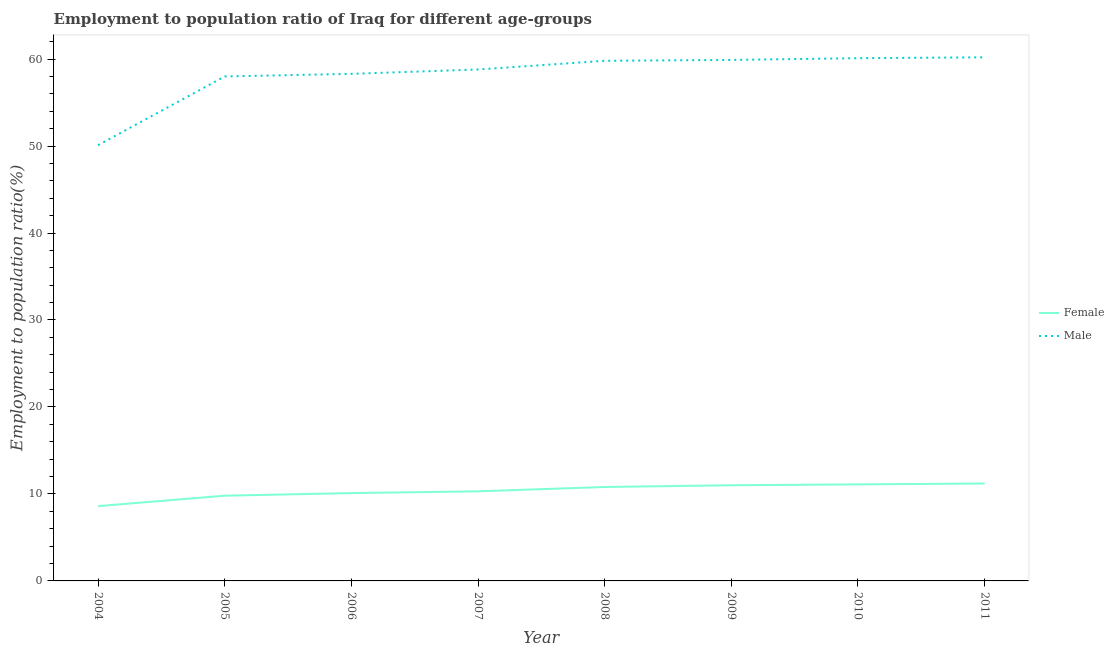Does the line corresponding to employment to population ratio(male) intersect with the line corresponding to employment to population ratio(female)?
Ensure brevity in your answer.  No. Across all years, what is the maximum employment to population ratio(male)?
Provide a succinct answer. 60.2. Across all years, what is the minimum employment to population ratio(male)?
Your answer should be compact. 50.1. In which year was the employment to population ratio(male) minimum?
Provide a short and direct response. 2004. What is the total employment to population ratio(male) in the graph?
Your answer should be compact. 465.2. What is the difference between the employment to population ratio(female) in 2005 and that in 2007?
Make the answer very short. -0.5. What is the difference between the employment to population ratio(female) in 2011 and the employment to population ratio(male) in 2004?
Offer a very short reply. -38.9. What is the average employment to population ratio(female) per year?
Offer a terse response. 10.36. In the year 2004, what is the difference between the employment to population ratio(female) and employment to population ratio(male)?
Your answer should be very brief. -41.5. What is the ratio of the employment to population ratio(female) in 2005 to that in 2009?
Make the answer very short. 0.89. Is the employment to population ratio(female) in 2008 less than that in 2010?
Ensure brevity in your answer.  Yes. What is the difference between the highest and the second highest employment to population ratio(male)?
Offer a terse response. 0.1. What is the difference between the highest and the lowest employment to population ratio(female)?
Your response must be concise. 2.6. In how many years, is the employment to population ratio(female) greater than the average employment to population ratio(female) taken over all years?
Your answer should be compact. 4. Is the sum of the employment to population ratio(male) in 2004 and 2006 greater than the maximum employment to population ratio(female) across all years?
Give a very brief answer. Yes. Does the employment to population ratio(female) monotonically increase over the years?
Your answer should be compact. Yes. How many lines are there?
Your answer should be very brief. 2. How many years are there in the graph?
Provide a succinct answer. 8. What is the difference between two consecutive major ticks on the Y-axis?
Your response must be concise. 10. Are the values on the major ticks of Y-axis written in scientific E-notation?
Your answer should be compact. No. Does the graph contain any zero values?
Your answer should be very brief. No. Does the graph contain grids?
Keep it short and to the point. No. Where does the legend appear in the graph?
Ensure brevity in your answer.  Center right. What is the title of the graph?
Your answer should be very brief. Employment to population ratio of Iraq for different age-groups. Does "Forest" appear as one of the legend labels in the graph?
Give a very brief answer. No. What is the label or title of the Y-axis?
Provide a succinct answer. Employment to population ratio(%). What is the Employment to population ratio(%) in Female in 2004?
Your answer should be compact. 8.6. What is the Employment to population ratio(%) of Male in 2004?
Keep it short and to the point. 50.1. What is the Employment to population ratio(%) of Female in 2005?
Make the answer very short. 9.8. What is the Employment to population ratio(%) in Male in 2005?
Your response must be concise. 58. What is the Employment to population ratio(%) of Female in 2006?
Offer a very short reply. 10.1. What is the Employment to population ratio(%) in Male in 2006?
Provide a short and direct response. 58.3. What is the Employment to population ratio(%) in Female in 2007?
Your answer should be compact. 10.3. What is the Employment to population ratio(%) in Male in 2007?
Your answer should be compact. 58.8. What is the Employment to population ratio(%) in Female in 2008?
Provide a short and direct response. 10.8. What is the Employment to population ratio(%) in Male in 2008?
Keep it short and to the point. 59.8. What is the Employment to population ratio(%) in Female in 2009?
Your response must be concise. 11. What is the Employment to population ratio(%) in Male in 2009?
Offer a very short reply. 59.9. What is the Employment to population ratio(%) in Female in 2010?
Keep it short and to the point. 11.1. What is the Employment to population ratio(%) in Male in 2010?
Your answer should be compact. 60.1. What is the Employment to population ratio(%) in Female in 2011?
Offer a very short reply. 11.2. What is the Employment to population ratio(%) of Male in 2011?
Your answer should be compact. 60.2. Across all years, what is the maximum Employment to population ratio(%) of Female?
Ensure brevity in your answer.  11.2. Across all years, what is the maximum Employment to population ratio(%) in Male?
Your answer should be very brief. 60.2. Across all years, what is the minimum Employment to population ratio(%) in Female?
Give a very brief answer. 8.6. Across all years, what is the minimum Employment to population ratio(%) of Male?
Ensure brevity in your answer.  50.1. What is the total Employment to population ratio(%) of Female in the graph?
Make the answer very short. 82.9. What is the total Employment to population ratio(%) of Male in the graph?
Ensure brevity in your answer.  465.2. What is the difference between the Employment to population ratio(%) in Female in 2004 and that in 2005?
Ensure brevity in your answer.  -1.2. What is the difference between the Employment to population ratio(%) of Male in 2004 and that in 2007?
Keep it short and to the point. -8.7. What is the difference between the Employment to population ratio(%) in Female in 2004 and that in 2008?
Your answer should be compact. -2.2. What is the difference between the Employment to population ratio(%) of Female in 2004 and that in 2009?
Your answer should be very brief. -2.4. What is the difference between the Employment to population ratio(%) of Female in 2004 and that in 2011?
Provide a short and direct response. -2.6. What is the difference between the Employment to population ratio(%) of Male in 2004 and that in 2011?
Ensure brevity in your answer.  -10.1. What is the difference between the Employment to population ratio(%) of Male in 2005 and that in 2006?
Keep it short and to the point. -0.3. What is the difference between the Employment to population ratio(%) of Female in 2005 and that in 2008?
Offer a terse response. -1. What is the difference between the Employment to population ratio(%) in Male in 2005 and that in 2008?
Provide a succinct answer. -1.8. What is the difference between the Employment to population ratio(%) of Female in 2005 and that in 2009?
Your answer should be very brief. -1.2. What is the difference between the Employment to population ratio(%) of Male in 2005 and that in 2009?
Give a very brief answer. -1.9. What is the difference between the Employment to population ratio(%) of Female in 2005 and that in 2010?
Provide a short and direct response. -1.3. What is the difference between the Employment to population ratio(%) in Male in 2005 and that in 2011?
Provide a succinct answer. -2.2. What is the difference between the Employment to population ratio(%) in Female in 2006 and that in 2008?
Your response must be concise. -0.7. What is the difference between the Employment to population ratio(%) of Female in 2006 and that in 2009?
Provide a succinct answer. -0.9. What is the difference between the Employment to population ratio(%) of Male in 2006 and that in 2009?
Make the answer very short. -1.6. What is the difference between the Employment to population ratio(%) in Female in 2007 and that in 2008?
Your answer should be very brief. -0.5. What is the difference between the Employment to population ratio(%) in Male in 2007 and that in 2008?
Your response must be concise. -1. What is the difference between the Employment to population ratio(%) of Female in 2007 and that in 2009?
Your response must be concise. -0.7. What is the difference between the Employment to population ratio(%) of Male in 2007 and that in 2009?
Keep it short and to the point. -1.1. What is the difference between the Employment to population ratio(%) in Male in 2007 and that in 2010?
Provide a short and direct response. -1.3. What is the difference between the Employment to population ratio(%) of Male in 2007 and that in 2011?
Offer a terse response. -1.4. What is the difference between the Employment to population ratio(%) in Male in 2008 and that in 2009?
Offer a very short reply. -0.1. What is the difference between the Employment to population ratio(%) of Female in 2009 and that in 2010?
Your answer should be very brief. -0.1. What is the difference between the Employment to population ratio(%) of Male in 2009 and that in 2010?
Give a very brief answer. -0.2. What is the difference between the Employment to population ratio(%) in Female in 2009 and that in 2011?
Your response must be concise. -0.2. What is the difference between the Employment to population ratio(%) in Male in 2009 and that in 2011?
Offer a terse response. -0.3. What is the difference between the Employment to population ratio(%) in Female in 2004 and the Employment to population ratio(%) in Male in 2005?
Your answer should be very brief. -49.4. What is the difference between the Employment to population ratio(%) of Female in 2004 and the Employment to population ratio(%) of Male in 2006?
Provide a succinct answer. -49.7. What is the difference between the Employment to population ratio(%) of Female in 2004 and the Employment to population ratio(%) of Male in 2007?
Ensure brevity in your answer.  -50.2. What is the difference between the Employment to population ratio(%) of Female in 2004 and the Employment to population ratio(%) of Male in 2008?
Offer a very short reply. -51.2. What is the difference between the Employment to population ratio(%) in Female in 2004 and the Employment to population ratio(%) in Male in 2009?
Your response must be concise. -51.3. What is the difference between the Employment to population ratio(%) of Female in 2004 and the Employment to population ratio(%) of Male in 2010?
Your answer should be very brief. -51.5. What is the difference between the Employment to population ratio(%) of Female in 2004 and the Employment to population ratio(%) of Male in 2011?
Offer a terse response. -51.6. What is the difference between the Employment to population ratio(%) in Female in 2005 and the Employment to population ratio(%) in Male in 2006?
Keep it short and to the point. -48.5. What is the difference between the Employment to population ratio(%) of Female in 2005 and the Employment to population ratio(%) of Male in 2007?
Provide a short and direct response. -49. What is the difference between the Employment to population ratio(%) of Female in 2005 and the Employment to population ratio(%) of Male in 2008?
Keep it short and to the point. -50. What is the difference between the Employment to population ratio(%) of Female in 2005 and the Employment to population ratio(%) of Male in 2009?
Give a very brief answer. -50.1. What is the difference between the Employment to population ratio(%) in Female in 2005 and the Employment to population ratio(%) in Male in 2010?
Your answer should be very brief. -50.3. What is the difference between the Employment to population ratio(%) of Female in 2005 and the Employment to population ratio(%) of Male in 2011?
Your answer should be compact. -50.4. What is the difference between the Employment to population ratio(%) in Female in 2006 and the Employment to population ratio(%) in Male in 2007?
Give a very brief answer. -48.7. What is the difference between the Employment to population ratio(%) of Female in 2006 and the Employment to population ratio(%) of Male in 2008?
Offer a terse response. -49.7. What is the difference between the Employment to population ratio(%) of Female in 2006 and the Employment to population ratio(%) of Male in 2009?
Ensure brevity in your answer.  -49.8. What is the difference between the Employment to population ratio(%) of Female in 2006 and the Employment to population ratio(%) of Male in 2011?
Ensure brevity in your answer.  -50.1. What is the difference between the Employment to population ratio(%) of Female in 2007 and the Employment to population ratio(%) of Male in 2008?
Your answer should be compact. -49.5. What is the difference between the Employment to population ratio(%) of Female in 2007 and the Employment to population ratio(%) of Male in 2009?
Ensure brevity in your answer.  -49.6. What is the difference between the Employment to population ratio(%) in Female in 2007 and the Employment to population ratio(%) in Male in 2010?
Provide a short and direct response. -49.8. What is the difference between the Employment to population ratio(%) in Female in 2007 and the Employment to population ratio(%) in Male in 2011?
Ensure brevity in your answer.  -49.9. What is the difference between the Employment to population ratio(%) in Female in 2008 and the Employment to population ratio(%) in Male in 2009?
Keep it short and to the point. -49.1. What is the difference between the Employment to population ratio(%) of Female in 2008 and the Employment to population ratio(%) of Male in 2010?
Offer a terse response. -49.3. What is the difference between the Employment to population ratio(%) of Female in 2008 and the Employment to population ratio(%) of Male in 2011?
Provide a short and direct response. -49.4. What is the difference between the Employment to population ratio(%) of Female in 2009 and the Employment to population ratio(%) of Male in 2010?
Your response must be concise. -49.1. What is the difference between the Employment to population ratio(%) of Female in 2009 and the Employment to population ratio(%) of Male in 2011?
Your answer should be very brief. -49.2. What is the difference between the Employment to population ratio(%) of Female in 2010 and the Employment to population ratio(%) of Male in 2011?
Keep it short and to the point. -49.1. What is the average Employment to population ratio(%) of Female per year?
Make the answer very short. 10.36. What is the average Employment to population ratio(%) in Male per year?
Provide a succinct answer. 58.15. In the year 2004, what is the difference between the Employment to population ratio(%) of Female and Employment to population ratio(%) of Male?
Make the answer very short. -41.5. In the year 2005, what is the difference between the Employment to population ratio(%) of Female and Employment to population ratio(%) of Male?
Offer a very short reply. -48.2. In the year 2006, what is the difference between the Employment to population ratio(%) of Female and Employment to population ratio(%) of Male?
Provide a succinct answer. -48.2. In the year 2007, what is the difference between the Employment to population ratio(%) in Female and Employment to population ratio(%) in Male?
Give a very brief answer. -48.5. In the year 2008, what is the difference between the Employment to population ratio(%) of Female and Employment to population ratio(%) of Male?
Your response must be concise. -49. In the year 2009, what is the difference between the Employment to population ratio(%) in Female and Employment to population ratio(%) in Male?
Provide a short and direct response. -48.9. In the year 2010, what is the difference between the Employment to population ratio(%) of Female and Employment to population ratio(%) of Male?
Provide a succinct answer. -49. In the year 2011, what is the difference between the Employment to population ratio(%) of Female and Employment to population ratio(%) of Male?
Offer a very short reply. -49. What is the ratio of the Employment to population ratio(%) of Female in 2004 to that in 2005?
Keep it short and to the point. 0.88. What is the ratio of the Employment to population ratio(%) in Male in 2004 to that in 2005?
Offer a very short reply. 0.86. What is the ratio of the Employment to population ratio(%) of Female in 2004 to that in 2006?
Your response must be concise. 0.85. What is the ratio of the Employment to population ratio(%) of Male in 2004 to that in 2006?
Keep it short and to the point. 0.86. What is the ratio of the Employment to population ratio(%) in Female in 2004 to that in 2007?
Provide a succinct answer. 0.83. What is the ratio of the Employment to population ratio(%) of Male in 2004 to that in 2007?
Give a very brief answer. 0.85. What is the ratio of the Employment to population ratio(%) in Female in 2004 to that in 2008?
Keep it short and to the point. 0.8. What is the ratio of the Employment to population ratio(%) of Male in 2004 to that in 2008?
Ensure brevity in your answer.  0.84. What is the ratio of the Employment to population ratio(%) in Female in 2004 to that in 2009?
Offer a very short reply. 0.78. What is the ratio of the Employment to population ratio(%) in Male in 2004 to that in 2009?
Your response must be concise. 0.84. What is the ratio of the Employment to population ratio(%) in Female in 2004 to that in 2010?
Your answer should be compact. 0.77. What is the ratio of the Employment to population ratio(%) of Male in 2004 to that in 2010?
Provide a short and direct response. 0.83. What is the ratio of the Employment to population ratio(%) of Female in 2004 to that in 2011?
Offer a very short reply. 0.77. What is the ratio of the Employment to population ratio(%) of Male in 2004 to that in 2011?
Provide a short and direct response. 0.83. What is the ratio of the Employment to population ratio(%) in Female in 2005 to that in 2006?
Keep it short and to the point. 0.97. What is the ratio of the Employment to population ratio(%) in Male in 2005 to that in 2006?
Provide a succinct answer. 0.99. What is the ratio of the Employment to population ratio(%) in Female in 2005 to that in 2007?
Your answer should be compact. 0.95. What is the ratio of the Employment to population ratio(%) in Male in 2005 to that in 2007?
Give a very brief answer. 0.99. What is the ratio of the Employment to population ratio(%) in Female in 2005 to that in 2008?
Offer a terse response. 0.91. What is the ratio of the Employment to population ratio(%) in Male in 2005 to that in 2008?
Give a very brief answer. 0.97. What is the ratio of the Employment to population ratio(%) in Female in 2005 to that in 2009?
Your response must be concise. 0.89. What is the ratio of the Employment to population ratio(%) in Male in 2005 to that in 2009?
Your answer should be compact. 0.97. What is the ratio of the Employment to population ratio(%) in Female in 2005 to that in 2010?
Give a very brief answer. 0.88. What is the ratio of the Employment to population ratio(%) in Male in 2005 to that in 2010?
Your response must be concise. 0.97. What is the ratio of the Employment to population ratio(%) in Female in 2005 to that in 2011?
Offer a very short reply. 0.88. What is the ratio of the Employment to population ratio(%) of Male in 2005 to that in 2011?
Give a very brief answer. 0.96. What is the ratio of the Employment to population ratio(%) in Female in 2006 to that in 2007?
Provide a short and direct response. 0.98. What is the ratio of the Employment to population ratio(%) in Male in 2006 to that in 2007?
Give a very brief answer. 0.99. What is the ratio of the Employment to population ratio(%) in Female in 2006 to that in 2008?
Your answer should be very brief. 0.94. What is the ratio of the Employment to population ratio(%) of Male in 2006 to that in 2008?
Give a very brief answer. 0.97. What is the ratio of the Employment to population ratio(%) in Female in 2006 to that in 2009?
Provide a succinct answer. 0.92. What is the ratio of the Employment to population ratio(%) of Male in 2006 to that in 2009?
Your answer should be compact. 0.97. What is the ratio of the Employment to population ratio(%) of Female in 2006 to that in 2010?
Provide a succinct answer. 0.91. What is the ratio of the Employment to population ratio(%) of Male in 2006 to that in 2010?
Your answer should be compact. 0.97. What is the ratio of the Employment to population ratio(%) of Female in 2006 to that in 2011?
Offer a terse response. 0.9. What is the ratio of the Employment to population ratio(%) of Male in 2006 to that in 2011?
Make the answer very short. 0.97. What is the ratio of the Employment to population ratio(%) of Female in 2007 to that in 2008?
Your answer should be very brief. 0.95. What is the ratio of the Employment to population ratio(%) of Male in 2007 to that in 2008?
Keep it short and to the point. 0.98. What is the ratio of the Employment to population ratio(%) in Female in 2007 to that in 2009?
Ensure brevity in your answer.  0.94. What is the ratio of the Employment to population ratio(%) in Male in 2007 to that in 2009?
Offer a terse response. 0.98. What is the ratio of the Employment to population ratio(%) in Female in 2007 to that in 2010?
Make the answer very short. 0.93. What is the ratio of the Employment to population ratio(%) of Male in 2007 to that in 2010?
Your answer should be compact. 0.98. What is the ratio of the Employment to population ratio(%) of Female in 2007 to that in 2011?
Your answer should be very brief. 0.92. What is the ratio of the Employment to population ratio(%) in Male in 2007 to that in 2011?
Provide a succinct answer. 0.98. What is the ratio of the Employment to population ratio(%) in Female in 2008 to that in 2009?
Your response must be concise. 0.98. What is the ratio of the Employment to population ratio(%) of Female in 2008 to that in 2010?
Provide a succinct answer. 0.97. What is the ratio of the Employment to population ratio(%) of Male in 2008 to that in 2010?
Keep it short and to the point. 0.99. What is the ratio of the Employment to population ratio(%) of Male in 2008 to that in 2011?
Provide a succinct answer. 0.99. What is the ratio of the Employment to population ratio(%) in Female in 2009 to that in 2010?
Give a very brief answer. 0.99. What is the ratio of the Employment to population ratio(%) in Male in 2009 to that in 2010?
Ensure brevity in your answer.  1. What is the ratio of the Employment to population ratio(%) of Female in 2009 to that in 2011?
Provide a short and direct response. 0.98. What is the difference between the highest and the second highest Employment to population ratio(%) in Male?
Your answer should be compact. 0.1. What is the difference between the highest and the lowest Employment to population ratio(%) of Female?
Your answer should be very brief. 2.6. What is the difference between the highest and the lowest Employment to population ratio(%) in Male?
Make the answer very short. 10.1. 